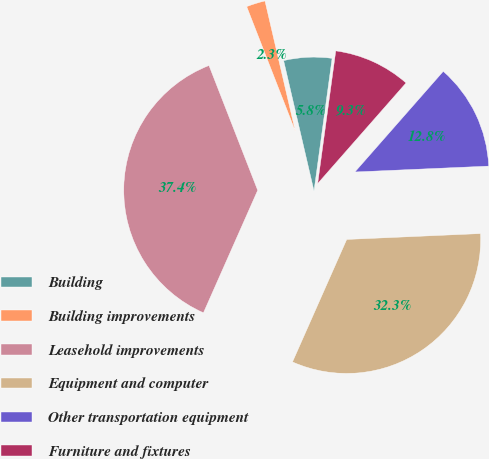Convert chart. <chart><loc_0><loc_0><loc_500><loc_500><pie_chart><fcel>Building<fcel>Building improvements<fcel>Leasehold improvements<fcel>Equipment and computer<fcel>Other transportation equipment<fcel>Furniture and fixtures<nl><fcel>5.8%<fcel>2.28%<fcel>37.44%<fcel>32.33%<fcel>12.83%<fcel>9.31%<nl></chart> 